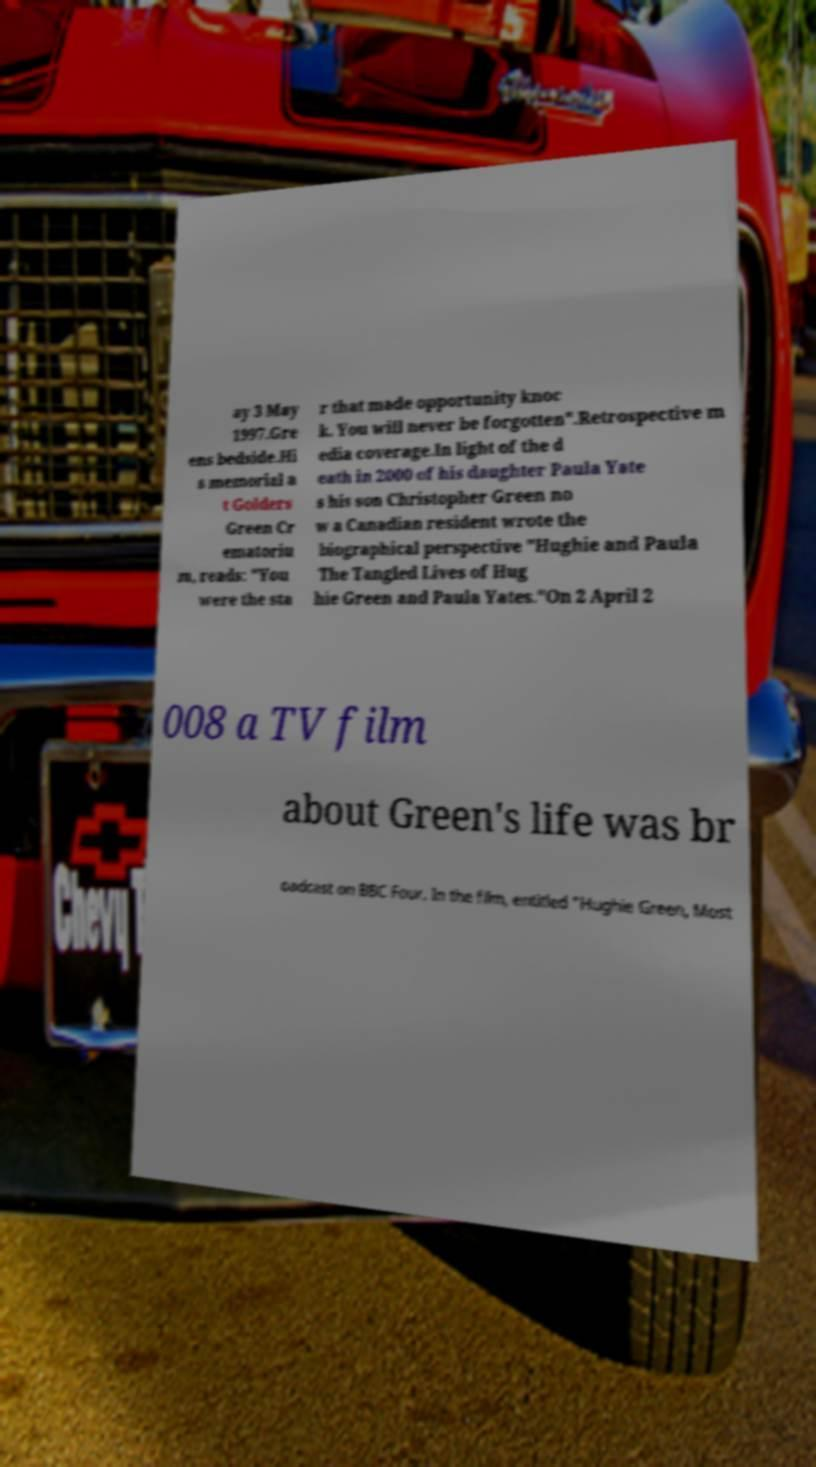Please identify and transcribe the text found in this image. ay 3 May 1997.Gre ens bedside.Hi s memorial a t Golders Green Cr ematoriu m, reads: "You were the sta r that made opportunity knoc k. You will never be forgotten".Retrospective m edia coverage.In light of the d eath in 2000 of his daughter Paula Yate s his son Christopher Green no w a Canadian resident wrote the biographical perspective "Hughie and Paula The Tangled Lives of Hug hie Green and Paula Yates."On 2 April 2 008 a TV film about Green's life was br oadcast on BBC Four. In the film, entitled "Hughie Green, Most 